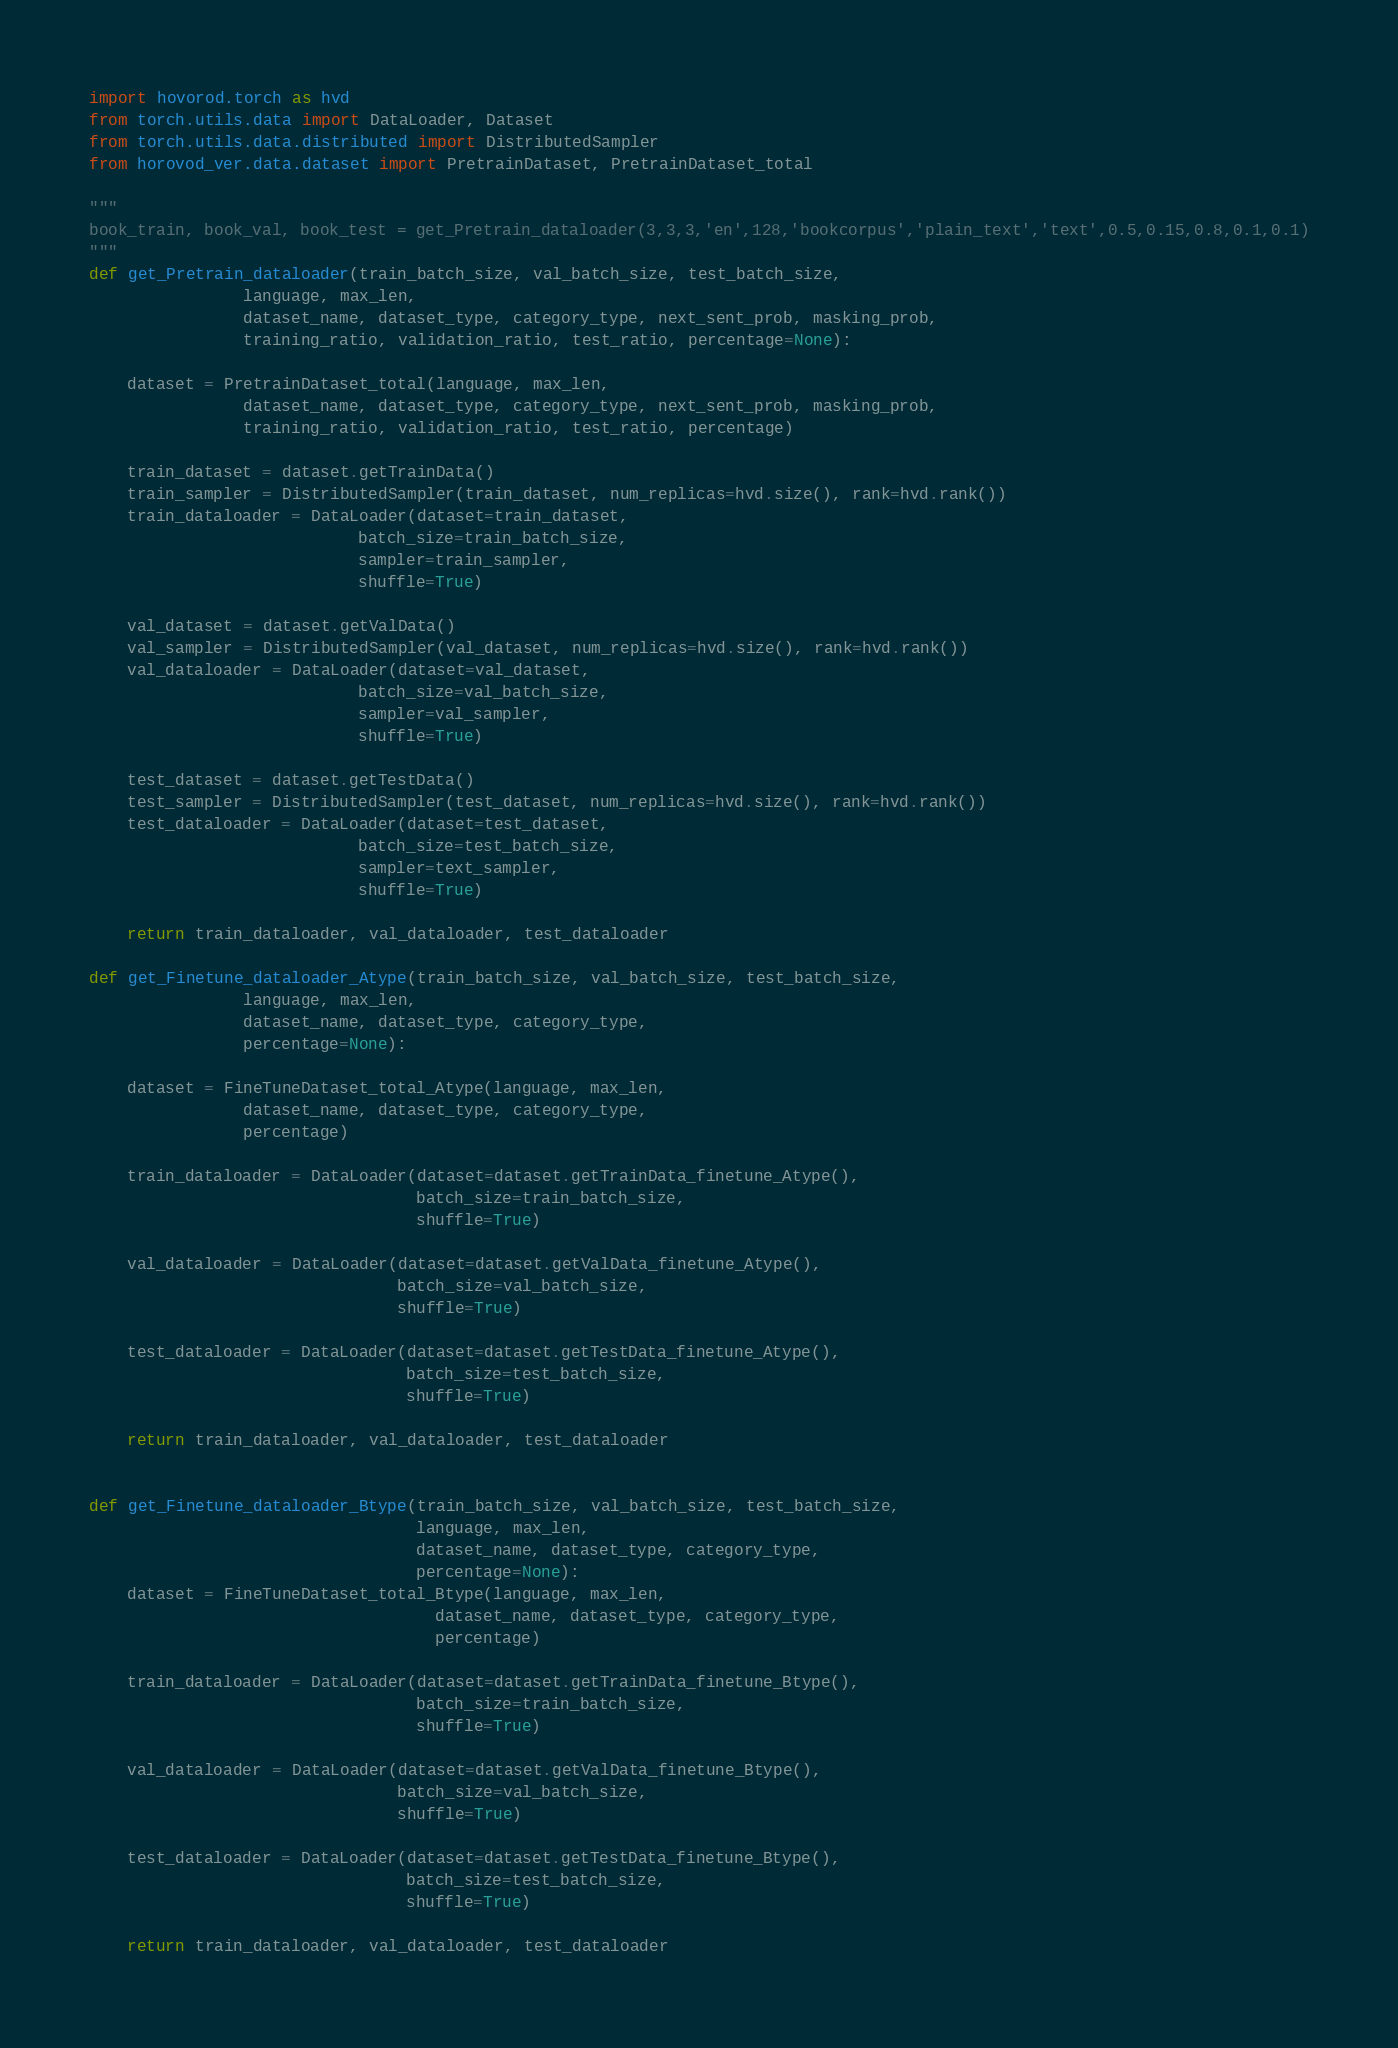Convert code to text. <code><loc_0><loc_0><loc_500><loc_500><_Python_>import hovorod.torch as hvd
from torch.utils.data import DataLoader, Dataset
from torch.utils.data.distributed import DistributedSampler
from horovod_ver.data.dataset import PretrainDataset, PretrainDataset_total

"""
book_train, book_val, book_test = get_Pretrain_dataloader(3,3,3,'en',128,'bookcorpus','plain_text','text',0.5,0.15,0.8,0.1,0.1)
"""
def get_Pretrain_dataloader(train_batch_size, val_batch_size, test_batch_size,
                language, max_len, 
                dataset_name, dataset_type, category_type, next_sent_prob, masking_prob, 
                training_ratio, validation_ratio, test_ratio, percentage=None):

    dataset = PretrainDataset_total(language, max_len, 
                dataset_name, dataset_type, category_type, next_sent_prob, masking_prob,
                training_ratio, validation_ratio, test_ratio, percentage)
    
    train_dataset = dataset.getTrainData()
    train_sampler = DistributedSampler(train_dataset, num_replicas=hvd.size(), rank=hvd.rank())
    train_dataloader = DataLoader(dataset=train_dataset,
                            batch_size=train_batch_size,
                            sampler=train_sampler,
                            shuffle=True)
    
    val_dataset = dataset.getValData()
    val_sampler = DistributedSampler(val_dataset, num_replicas=hvd.size(), rank=hvd.rank())
    val_dataloader = DataLoader(dataset=val_dataset,
                            batch_size=val_batch_size,
                            sampler=val_sampler,
                            shuffle=True)  
    
    test_dataset = dataset.getTestData()
    test_sampler = DistributedSampler(test_dataset, num_replicas=hvd.size(), rank=hvd.rank())
    test_dataloader = DataLoader(dataset=test_dataset,
                            batch_size=test_batch_size,
                            sampler=text_sampler,
                            shuffle=True)      
    
    return train_dataloader, val_dataloader, test_dataloader

def get_Finetune_dataloader_Atype(train_batch_size, val_batch_size, test_batch_size,
                language, max_len, 
                dataset_name, dataset_type, category_type,
                percentage=None):

    dataset = FineTuneDataset_total_Atype(language, max_len,
                dataset_name, dataset_type, category_type,
                percentage)
    
    train_dataloader = DataLoader(dataset=dataset.getTrainData_finetune_Atype(),
                                  batch_size=train_batch_size,
                                  shuffle=True)

    val_dataloader = DataLoader(dataset=dataset.getValData_finetune_Atype(),
                                batch_size=val_batch_size,
                                shuffle=True)
    
    test_dataloader = DataLoader(dataset=dataset.getTestData_finetune_Atype(),
                                 batch_size=test_batch_size,
                                 shuffle=True)
    
    return train_dataloader, val_dataloader, test_dataloader


def get_Finetune_dataloader_Btype(train_batch_size, val_batch_size, test_batch_size,
                                  language, max_len,
                                  dataset_name, dataset_type, category_type,
                                  percentage=None):
    dataset = FineTuneDataset_total_Btype(language, max_len,
                                    dataset_name, dataset_type, category_type,
                                    percentage)

    train_dataloader = DataLoader(dataset=dataset.getTrainData_finetune_Btype(),
                                  batch_size=train_batch_size,
                                  shuffle=True)

    val_dataloader = DataLoader(dataset=dataset.getValData_finetune_Btype(),
                                batch_size=val_batch_size,
                                shuffle=True)

    test_dataloader = DataLoader(dataset=dataset.getTestData_finetune_Btype(),
                                 batch_size=test_batch_size,
                                 shuffle=True)

    return train_dataloader, val_dataloader, test_dataloader


</code> 